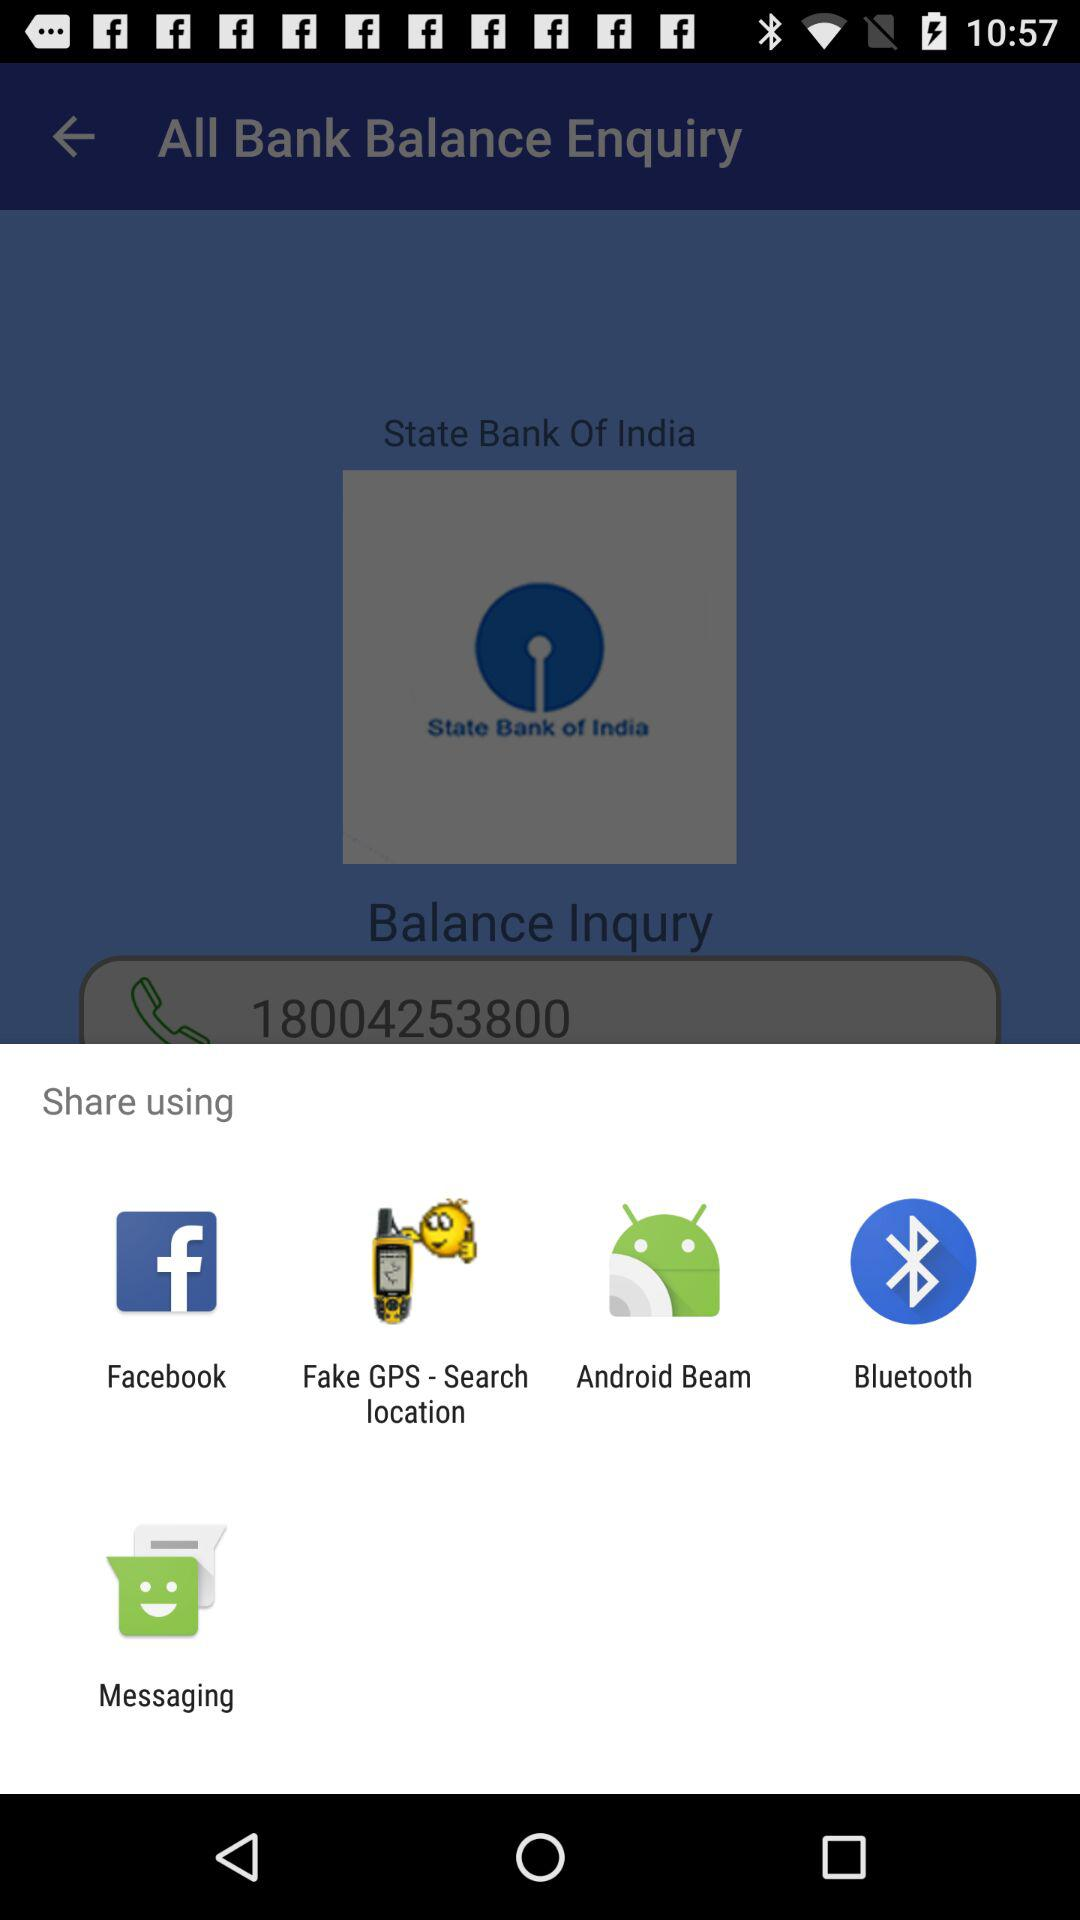What are the different sharing options? The different sharing options are "Facebook", "Fake GPS - Search location", "Android Beam", "Bluetooth", and "Messaging". 